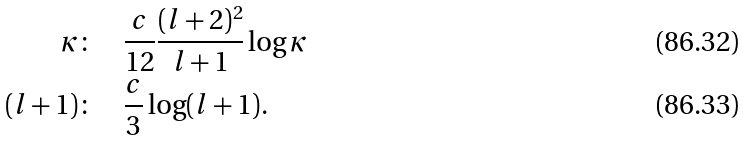<formula> <loc_0><loc_0><loc_500><loc_500>\kappa \colon \quad & \frac { c } { 1 2 } \frac { ( l + 2 ) ^ { 2 } } { l + 1 } \log \kappa \\ ( l + 1 ) \colon \quad & \frac { c } { 3 } \log ( l + 1 ) .</formula> 